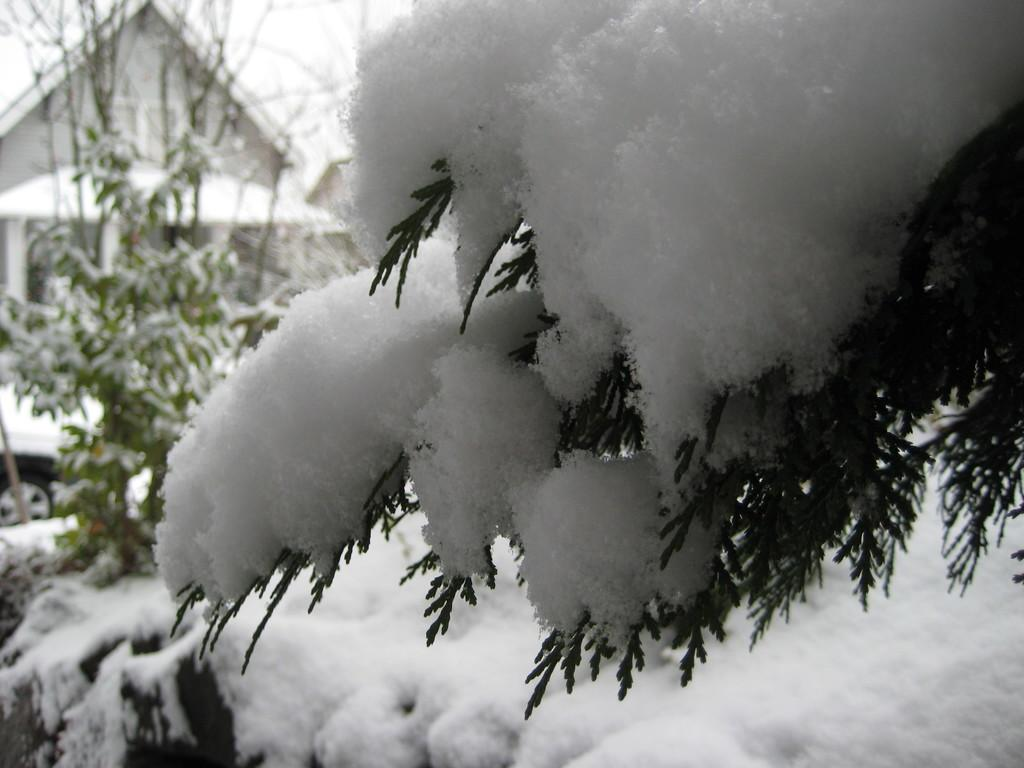What is in the foreground of the image? There are trees in the foreground of the image. What is the condition of the trees? The trees are covered with snow. What can be seen in the background of the image? There is a house in the background of the image. How many dimes are scattered on the snow-covered trees in the image? There are no dimes present in the image; the trees are covered with snow. Can you see any steam coming from the house in the background of the image? There is no mention of steam in the image, and the focus is on the snow-covered trees and the house in the background. 